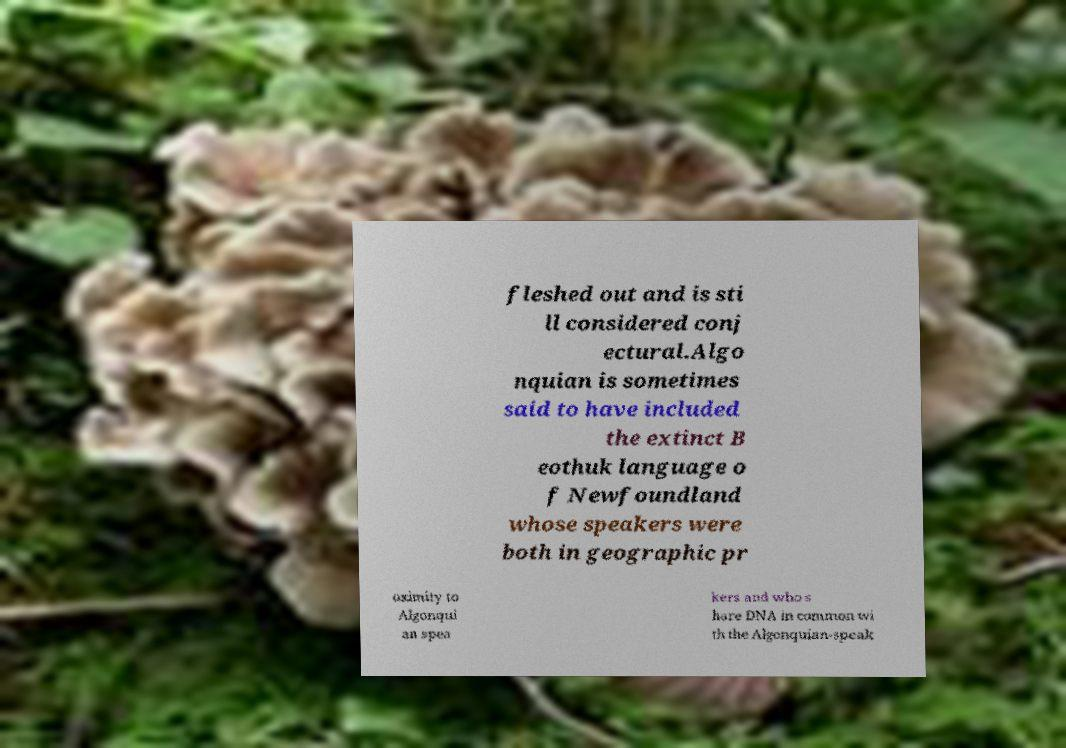Could you assist in decoding the text presented in this image and type it out clearly? fleshed out and is sti ll considered conj ectural.Algo nquian is sometimes said to have included the extinct B eothuk language o f Newfoundland whose speakers were both in geographic pr oximity to Algonqui an spea kers and who s hare DNA in common wi th the Algonquian-speak 